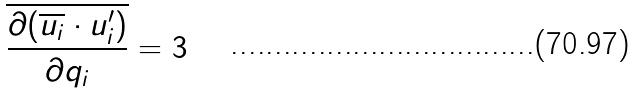Convert formula to latex. <formula><loc_0><loc_0><loc_500><loc_500>\overline { \frac { \partial ( \overline { u _ { i } } \cdot u _ { i } ^ { \prime } ) } { \partial q _ { i } } } = 3</formula> 